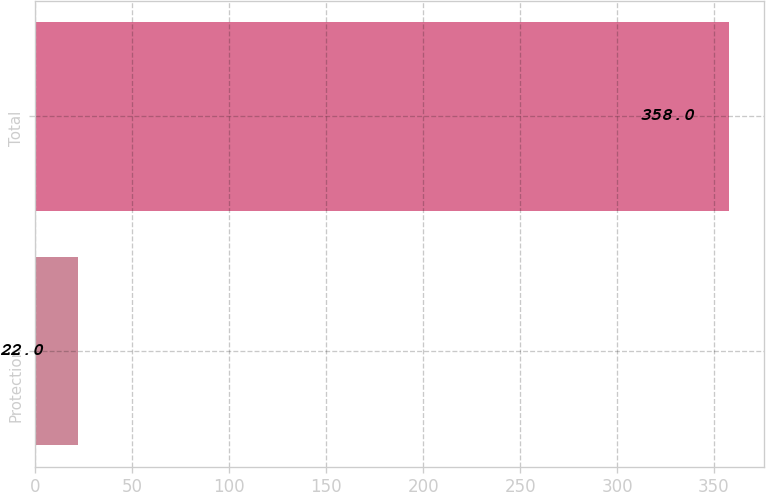Convert chart. <chart><loc_0><loc_0><loc_500><loc_500><bar_chart><fcel>Protection<fcel>Total<nl><fcel>22<fcel>358<nl></chart> 